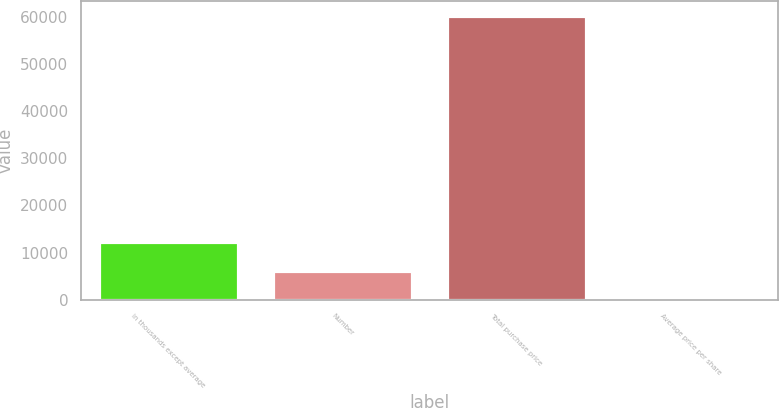Convert chart. <chart><loc_0><loc_0><loc_500><loc_500><bar_chart><fcel>in thousands except average<fcel>Number<fcel>Total purchase price<fcel>Average price per share<nl><fcel>12155.1<fcel>6136.66<fcel>60303<fcel>118.18<nl></chart> 